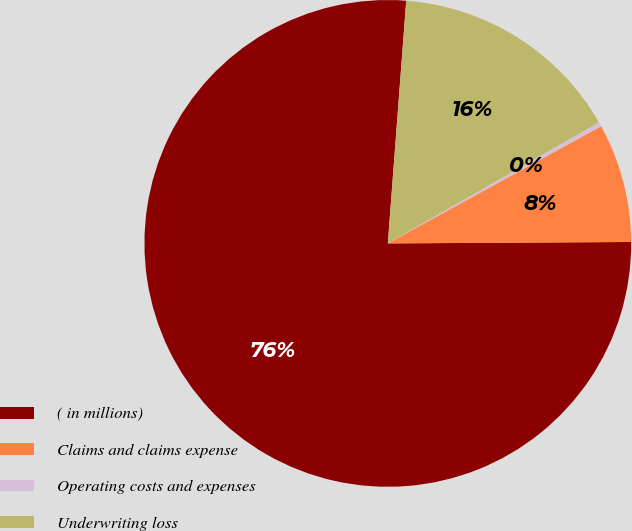<chart> <loc_0><loc_0><loc_500><loc_500><pie_chart><fcel>( in millions)<fcel>Claims and claims expense<fcel>Operating costs and expenses<fcel>Underwriting loss<nl><fcel>76.29%<fcel>7.9%<fcel>0.3%<fcel>15.5%<nl></chart> 